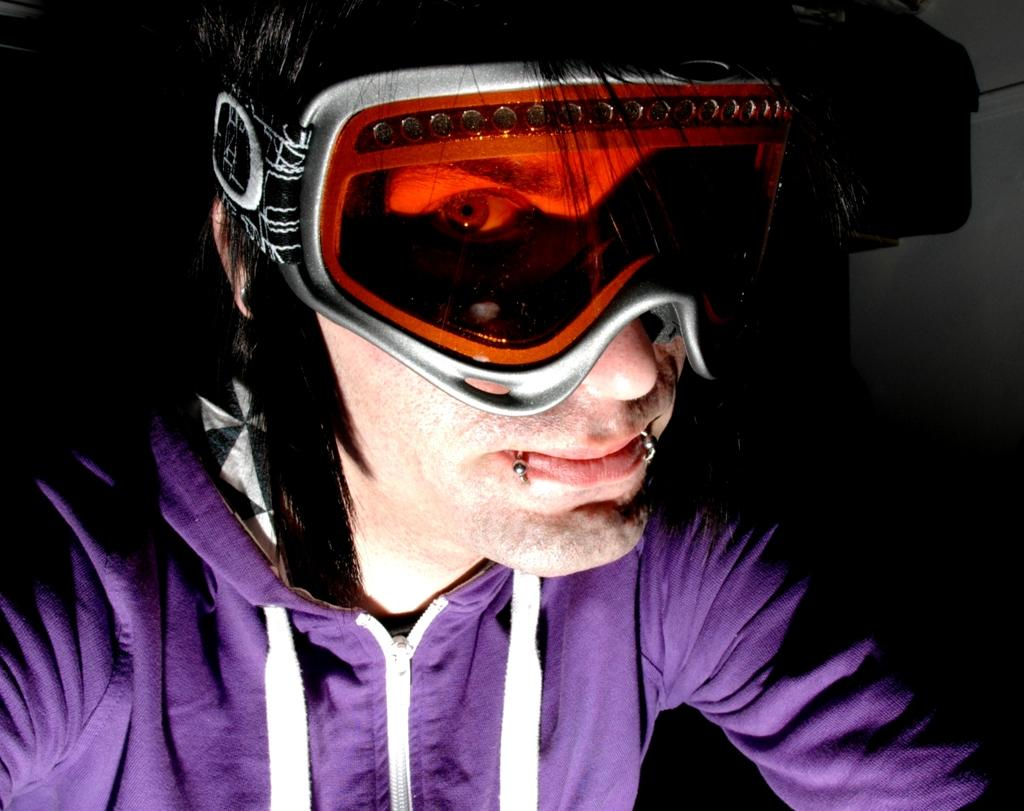Who is the main subject in the foreground of the image? There is a man in the foreground of the image. What is the man wearing on his face? The man is wearing goggles. What type of clothing is the man wearing on his upper body? The man is wearing a hoodie. What letter does the man receive in the morning while using the iron? There is no letter, morning, or iron present in the image. The man is wearing goggles and a hoodie, but there is no indication of any activity involving a letter or an iron. 